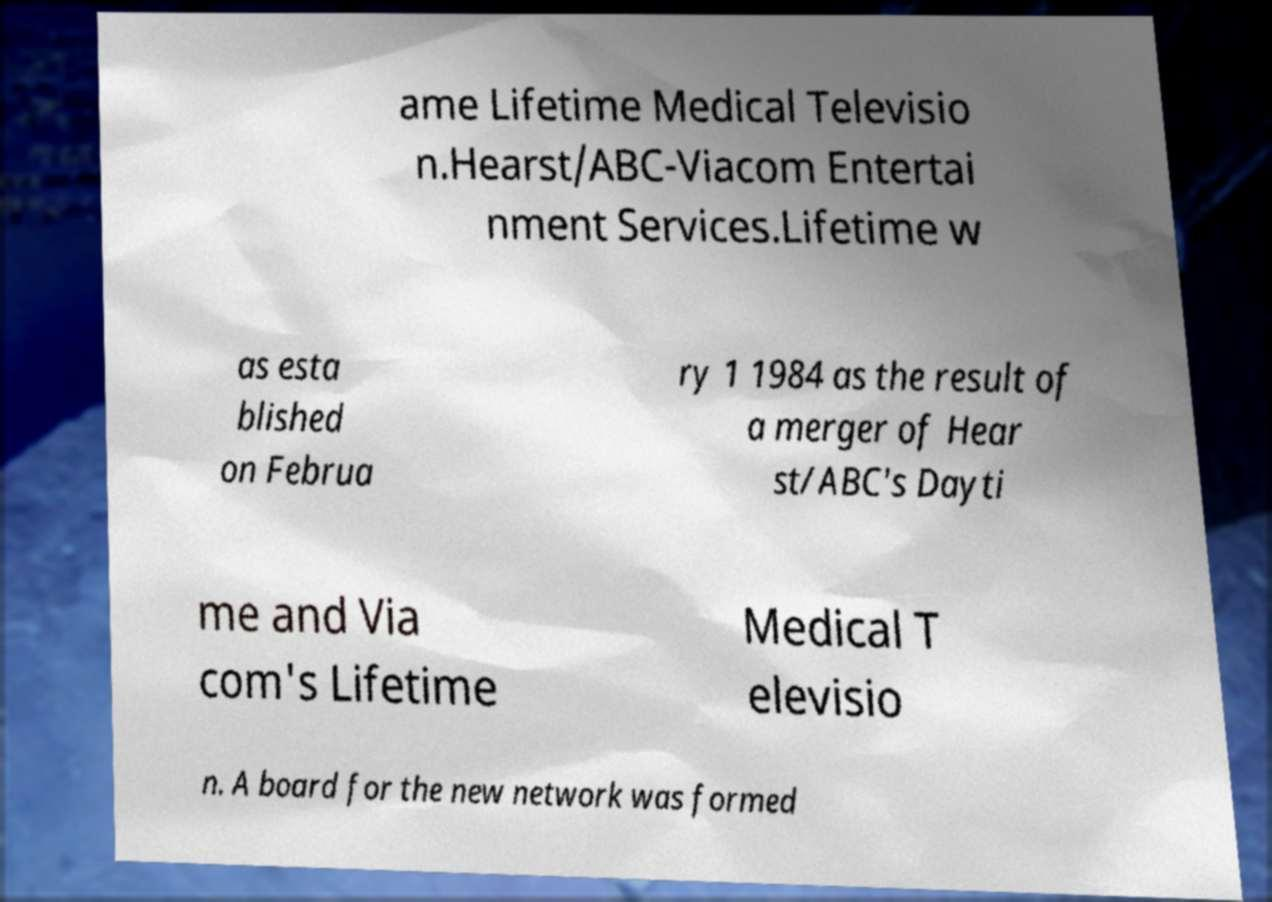Please identify and transcribe the text found in this image. ame Lifetime Medical Televisio n.Hearst/ABC-Viacom Entertai nment Services.Lifetime w as esta blished on Februa ry 1 1984 as the result of a merger of Hear st/ABC's Dayti me and Via com's Lifetime Medical T elevisio n. A board for the new network was formed 